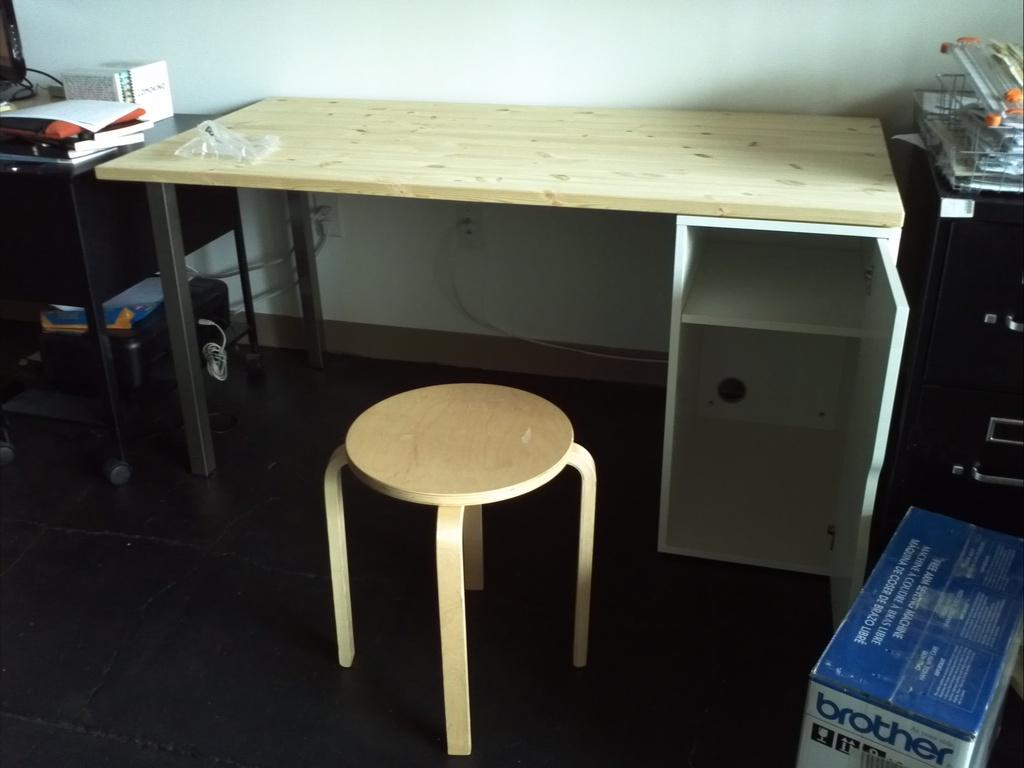Provide a one-sentence caption for the provided image. A wooden desk and stool in a cluttered room with a box that says brother. 